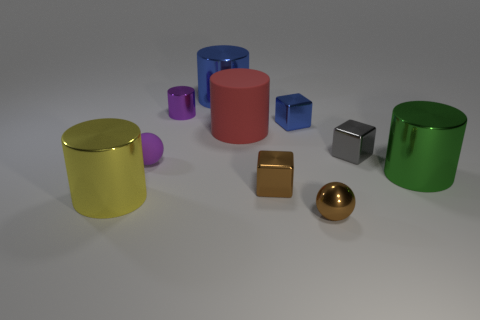What number of other things are the same shape as the large matte thing?
Your response must be concise. 4. Are there more cylinders to the left of the purple ball than small red matte cylinders?
Provide a short and direct response. Yes. The ball that is left of the red rubber thing is what color?
Make the answer very short. Purple. There is a object that is the same color as the rubber sphere; what size is it?
Make the answer very short. Small. What number of shiny things are either tiny purple things or big objects?
Keep it short and to the point. 4. There is a large shiny cylinder to the right of the small ball that is on the right side of the red cylinder; is there a small purple rubber sphere in front of it?
Your answer should be very brief. No. How many metallic things are on the right side of the large yellow cylinder?
Provide a short and direct response. 7. There is a ball that is the same color as the tiny metal cylinder; what is it made of?
Keep it short and to the point. Rubber. How many big objects are gray metal cubes or blue metallic blocks?
Your answer should be very brief. 0. What shape is the small rubber thing that is left of the gray shiny object?
Make the answer very short. Sphere. 